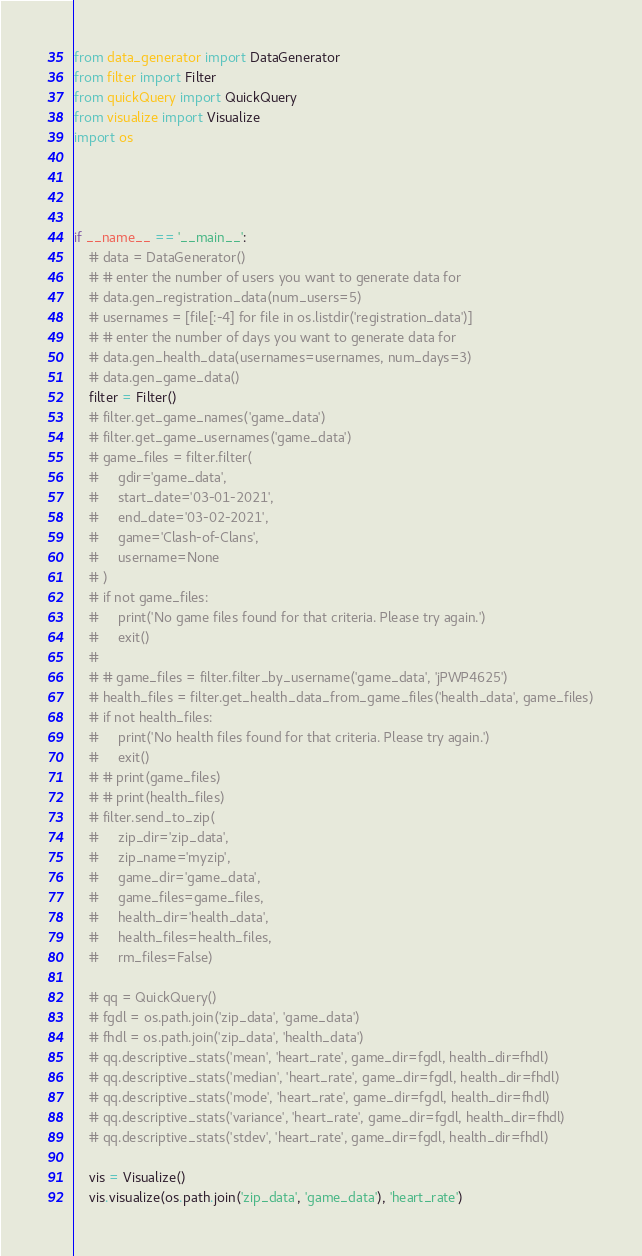Convert code to text. <code><loc_0><loc_0><loc_500><loc_500><_Python_>
from data_generator import DataGenerator
from filter import Filter
from quickQuery import QuickQuery
from visualize import Visualize
import os




if __name__ == '__main__':
    # data = DataGenerator()
    # # enter the number of users you want to generate data for
    # data.gen_registration_data(num_users=5)
    # usernames = [file[:-4] for file in os.listdir('registration_data')]
    # # enter the number of days you want to generate data for
    # data.gen_health_data(usernames=usernames, num_days=3)
    # data.gen_game_data()
    filter = Filter()
    # filter.get_game_names('game_data')
    # filter.get_game_usernames('game_data')
    # game_files = filter.filter(
    #     gdir='game_data',
    #     start_date='03-01-2021',
    #     end_date='03-02-2021',
    #     game='Clash-of-Clans',
    #     username=None
    # )
    # if not game_files:
    #     print('No game files found for that criteria. Please try again.')
    #     exit()
    #
    # # game_files = filter.filter_by_username('game_data', 'jPWP4625')
    # health_files = filter.get_health_data_from_game_files('health_data', game_files)
    # if not health_files:
    #     print('No health files found for that criteria. Please try again.')
    #     exit()
    # # print(game_files)
    # # print(health_files)
    # filter.send_to_zip(
    #     zip_dir='zip_data',
    #     zip_name='myzip',
    #     game_dir='game_data',
    #     game_files=game_files,
    #     health_dir='health_data',
    #     health_files=health_files,
    #     rm_files=False)

    # qq = QuickQuery()
    # fgdl = os.path.join('zip_data', 'game_data')
    # fhdl = os.path.join('zip_data', 'health_data')
    # qq.descriptive_stats('mean', 'heart_rate', game_dir=fgdl, health_dir=fhdl)
    # qq.descriptive_stats('median', 'heart_rate', game_dir=fgdl, health_dir=fhdl)
    # qq.descriptive_stats('mode', 'heart_rate', game_dir=fgdl, health_dir=fhdl)
    # qq.descriptive_stats('variance', 'heart_rate', game_dir=fgdl, health_dir=fhdl)
    # qq.descriptive_stats('stdev', 'heart_rate', game_dir=fgdl, health_dir=fhdl)

    vis = Visualize()
    vis.visualize(os.path.join('zip_data', 'game_data'), 'heart_rate')




</code> 